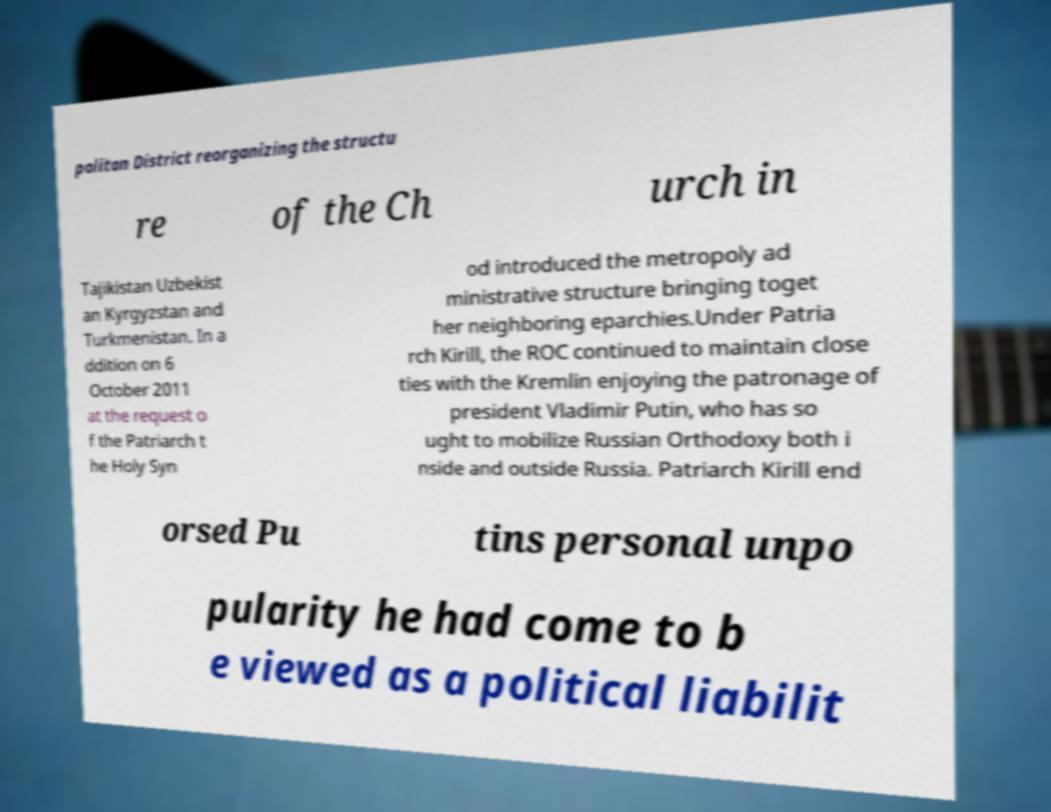Please identify and transcribe the text found in this image. politan District reorganizing the structu re of the Ch urch in Tajikistan Uzbekist an Kyrgyzstan and Turkmenistan. In a ddition on 6 October 2011 at the request o f the Patriarch t he Holy Syn od introduced the metropoly ad ministrative structure bringing toget her neighboring eparchies.Under Patria rch Kirill, the ROC continued to maintain close ties with the Kremlin enjoying the patronage of president Vladimir Putin, who has so ught to mobilize Russian Orthodoxy both i nside and outside Russia. Patriarch Kirill end orsed Pu tins personal unpo pularity he had come to b e viewed as a political liabilit 